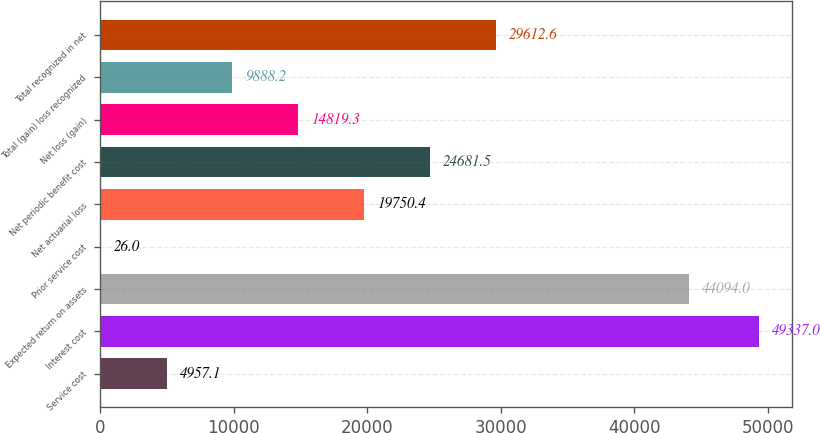<chart> <loc_0><loc_0><loc_500><loc_500><bar_chart><fcel>Service cost<fcel>Interest cost<fcel>Expected return on assets<fcel>Prior service cost<fcel>Net actuarial loss<fcel>Net periodic benefit cost<fcel>Net loss (gain)<fcel>Total (gain) loss recognized<fcel>Total recognized in net<nl><fcel>4957.1<fcel>49337<fcel>44094<fcel>26<fcel>19750.4<fcel>24681.5<fcel>14819.3<fcel>9888.2<fcel>29612.6<nl></chart> 